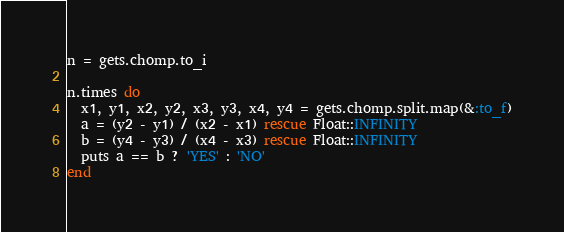Convert code to text. <code><loc_0><loc_0><loc_500><loc_500><_Ruby_>n = gets.chomp.to_i

n.times do
  x1, y1, x2, y2, x3, y3, x4, y4 = gets.chomp.split.map(&:to_f)
  a = (y2 - y1) / (x2 - x1) rescue Float::INFINITY
  b = (y4 - y3) / (x4 - x3) rescue Float::INFINITY
  puts a == b ? 'YES' : 'NO'
end</code> 